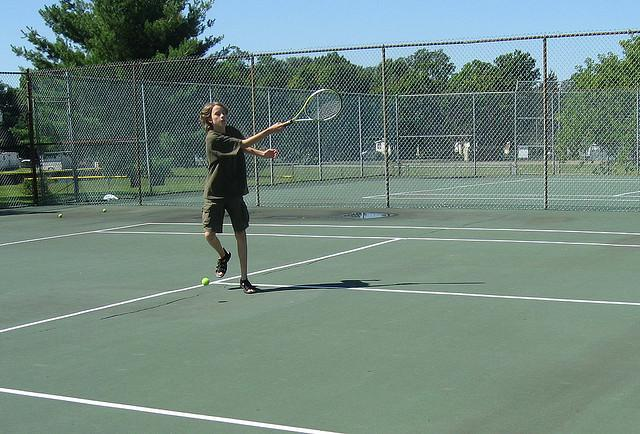What did the boy most likely just do to the ball with his racket?

Choices:
A) returned it
B) served it
C) missed it
D) launched it missed it 